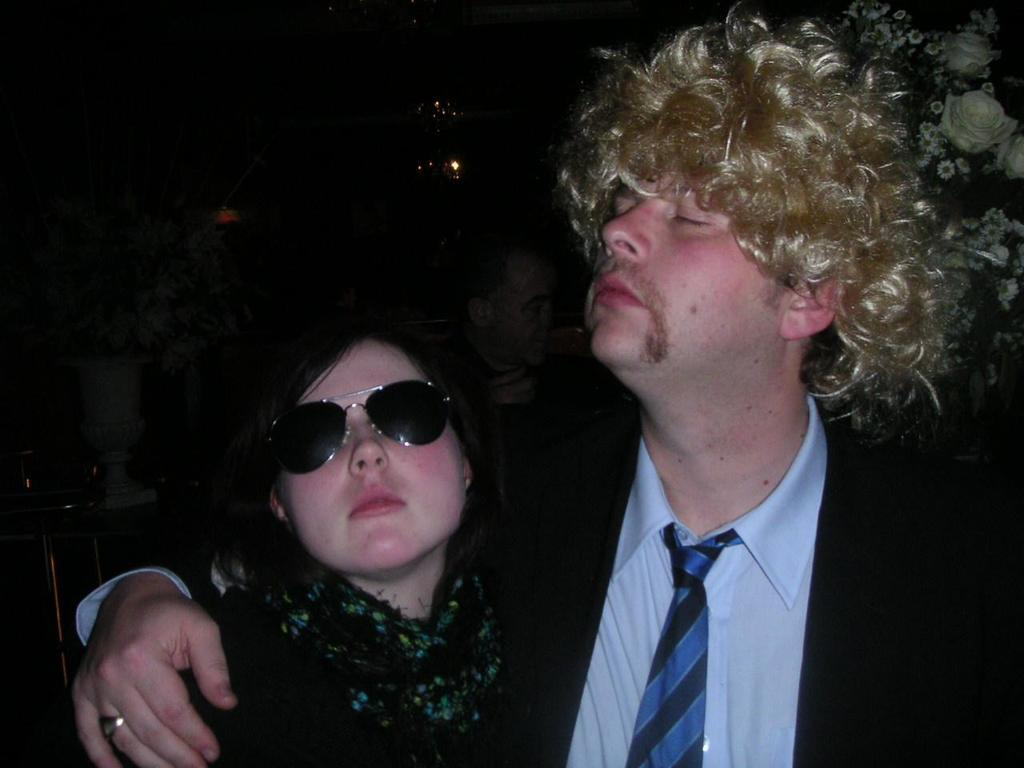How many people are in the image? There are two persons in the image. What are the people wearing in the image? Both persons are wearing black dress. Can you describe any specific accessories worn by the man? The man is wearing a wig. What type of eyewear is the woman wearing in the image? The woman is wearing shades. What type of unit can be seen in the image? There is no unit present in the image; it features two people wearing black dresses. What type of care is the man providing for the woman in the image? There is no indication in the image that the man is providing care for the woman, as they are both simply standing there. 